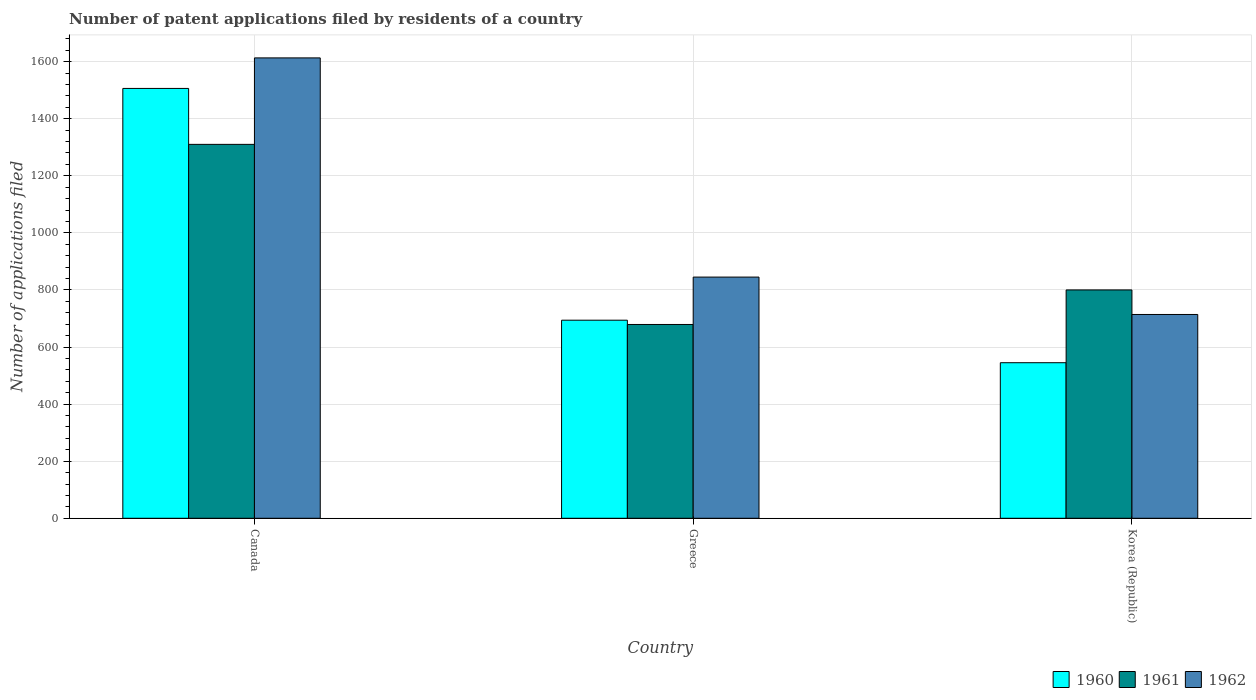How many different coloured bars are there?
Give a very brief answer. 3. What is the label of the 2nd group of bars from the left?
Ensure brevity in your answer.  Greece. In how many cases, is the number of bars for a given country not equal to the number of legend labels?
Make the answer very short. 0. What is the number of applications filed in 1961 in Greece?
Offer a terse response. 679. Across all countries, what is the maximum number of applications filed in 1960?
Give a very brief answer. 1506. Across all countries, what is the minimum number of applications filed in 1961?
Offer a very short reply. 679. In which country was the number of applications filed in 1960 maximum?
Offer a terse response. Canada. What is the total number of applications filed in 1962 in the graph?
Make the answer very short. 3172. What is the difference between the number of applications filed in 1961 in Greece and that in Korea (Republic)?
Make the answer very short. -121. What is the difference between the number of applications filed in 1962 in Canada and the number of applications filed in 1960 in Korea (Republic)?
Your answer should be very brief. 1068. What is the average number of applications filed in 1962 per country?
Your answer should be very brief. 1057.33. What is the difference between the number of applications filed of/in 1961 and number of applications filed of/in 1962 in Greece?
Your answer should be very brief. -166. In how many countries, is the number of applications filed in 1962 greater than 1560?
Offer a very short reply. 1. What is the ratio of the number of applications filed in 1961 in Greece to that in Korea (Republic)?
Offer a very short reply. 0.85. Is the number of applications filed in 1960 in Canada less than that in Korea (Republic)?
Ensure brevity in your answer.  No. Is the difference between the number of applications filed in 1961 in Greece and Korea (Republic) greater than the difference between the number of applications filed in 1962 in Greece and Korea (Republic)?
Provide a succinct answer. No. What is the difference between the highest and the second highest number of applications filed in 1962?
Your answer should be very brief. -131. What is the difference between the highest and the lowest number of applications filed in 1960?
Your answer should be very brief. 961. Is the sum of the number of applications filed in 1962 in Canada and Greece greater than the maximum number of applications filed in 1961 across all countries?
Your answer should be compact. Yes. What does the 2nd bar from the left in Korea (Republic) represents?
Provide a short and direct response. 1961. Is it the case that in every country, the sum of the number of applications filed in 1962 and number of applications filed in 1961 is greater than the number of applications filed in 1960?
Your answer should be very brief. Yes. Are all the bars in the graph horizontal?
Make the answer very short. No. Are the values on the major ticks of Y-axis written in scientific E-notation?
Ensure brevity in your answer.  No. Does the graph contain any zero values?
Your answer should be compact. No. Does the graph contain grids?
Your answer should be very brief. Yes. Where does the legend appear in the graph?
Ensure brevity in your answer.  Bottom right. How many legend labels are there?
Provide a succinct answer. 3. What is the title of the graph?
Ensure brevity in your answer.  Number of patent applications filed by residents of a country. What is the label or title of the X-axis?
Keep it short and to the point. Country. What is the label or title of the Y-axis?
Ensure brevity in your answer.  Number of applications filed. What is the Number of applications filed of 1960 in Canada?
Provide a succinct answer. 1506. What is the Number of applications filed in 1961 in Canada?
Keep it short and to the point. 1310. What is the Number of applications filed of 1962 in Canada?
Offer a very short reply. 1613. What is the Number of applications filed in 1960 in Greece?
Your response must be concise. 694. What is the Number of applications filed of 1961 in Greece?
Your answer should be very brief. 679. What is the Number of applications filed in 1962 in Greece?
Your answer should be very brief. 845. What is the Number of applications filed of 1960 in Korea (Republic)?
Offer a terse response. 545. What is the Number of applications filed in 1961 in Korea (Republic)?
Offer a very short reply. 800. What is the Number of applications filed in 1962 in Korea (Republic)?
Provide a succinct answer. 714. Across all countries, what is the maximum Number of applications filed in 1960?
Your answer should be compact. 1506. Across all countries, what is the maximum Number of applications filed of 1961?
Make the answer very short. 1310. Across all countries, what is the maximum Number of applications filed in 1962?
Keep it short and to the point. 1613. Across all countries, what is the minimum Number of applications filed in 1960?
Your response must be concise. 545. Across all countries, what is the minimum Number of applications filed in 1961?
Offer a terse response. 679. Across all countries, what is the minimum Number of applications filed in 1962?
Make the answer very short. 714. What is the total Number of applications filed in 1960 in the graph?
Your response must be concise. 2745. What is the total Number of applications filed of 1961 in the graph?
Your answer should be very brief. 2789. What is the total Number of applications filed of 1962 in the graph?
Keep it short and to the point. 3172. What is the difference between the Number of applications filed in 1960 in Canada and that in Greece?
Provide a short and direct response. 812. What is the difference between the Number of applications filed in 1961 in Canada and that in Greece?
Ensure brevity in your answer.  631. What is the difference between the Number of applications filed of 1962 in Canada and that in Greece?
Your answer should be compact. 768. What is the difference between the Number of applications filed of 1960 in Canada and that in Korea (Republic)?
Ensure brevity in your answer.  961. What is the difference between the Number of applications filed of 1961 in Canada and that in Korea (Republic)?
Give a very brief answer. 510. What is the difference between the Number of applications filed of 1962 in Canada and that in Korea (Republic)?
Offer a terse response. 899. What is the difference between the Number of applications filed in 1960 in Greece and that in Korea (Republic)?
Your answer should be compact. 149. What is the difference between the Number of applications filed in 1961 in Greece and that in Korea (Republic)?
Provide a succinct answer. -121. What is the difference between the Number of applications filed in 1962 in Greece and that in Korea (Republic)?
Keep it short and to the point. 131. What is the difference between the Number of applications filed in 1960 in Canada and the Number of applications filed in 1961 in Greece?
Make the answer very short. 827. What is the difference between the Number of applications filed in 1960 in Canada and the Number of applications filed in 1962 in Greece?
Ensure brevity in your answer.  661. What is the difference between the Number of applications filed in 1961 in Canada and the Number of applications filed in 1962 in Greece?
Ensure brevity in your answer.  465. What is the difference between the Number of applications filed in 1960 in Canada and the Number of applications filed in 1961 in Korea (Republic)?
Keep it short and to the point. 706. What is the difference between the Number of applications filed of 1960 in Canada and the Number of applications filed of 1962 in Korea (Republic)?
Provide a short and direct response. 792. What is the difference between the Number of applications filed in 1961 in Canada and the Number of applications filed in 1962 in Korea (Republic)?
Ensure brevity in your answer.  596. What is the difference between the Number of applications filed of 1960 in Greece and the Number of applications filed of 1961 in Korea (Republic)?
Provide a succinct answer. -106. What is the difference between the Number of applications filed in 1960 in Greece and the Number of applications filed in 1962 in Korea (Republic)?
Keep it short and to the point. -20. What is the difference between the Number of applications filed in 1961 in Greece and the Number of applications filed in 1962 in Korea (Republic)?
Your answer should be very brief. -35. What is the average Number of applications filed in 1960 per country?
Give a very brief answer. 915. What is the average Number of applications filed of 1961 per country?
Keep it short and to the point. 929.67. What is the average Number of applications filed of 1962 per country?
Your answer should be very brief. 1057.33. What is the difference between the Number of applications filed in 1960 and Number of applications filed in 1961 in Canada?
Your response must be concise. 196. What is the difference between the Number of applications filed in 1960 and Number of applications filed in 1962 in Canada?
Offer a very short reply. -107. What is the difference between the Number of applications filed in 1961 and Number of applications filed in 1962 in Canada?
Your response must be concise. -303. What is the difference between the Number of applications filed in 1960 and Number of applications filed in 1962 in Greece?
Your answer should be very brief. -151. What is the difference between the Number of applications filed of 1961 and Number of applications filed of 1962 in Greece?
Provide a succinct answer. -166. What is the difference between the Number of applications filed in 1960 and Number of applications filed in 1961 in Korea (Republic)?
Ensure brevity in your answer.  -255. What is the difference between the Number of applications filed in 1960 and Number of applications filed in 1962 in Korea (Republic)?
Make the answer very short. -169. What is the ratio of the Number of applications filed of 1960 in Canada to that in Greece?
Provide a succinct answer. 2.17. What is the ratio of the Number of applications filed of 1961 in Canada to that in Greece?
Your answer should be very brief. 1.93. What is the ratio of the Number of applications filed of 1962 in Canada to that in Greece?
Offer a very short reply. 1.91. What is the ratio of the Number of applications filed of 1960 in Canada to that in Korea (Republic)?
Keep it short and to the point. 2.76. What is the ratio of the Number of applications filed of 1961 in Canada to that in Korea (Republic)?
Offer a terse response. 1.64. What is the ratio of the Number of applications filed in 1962 in Canada to that in Korea (Republic)?
Give a very brief answer. 2.26. What is the ratio of the Number of applications filed in 1960 in Greece to that in Korea (Republic)?
Keep it short and to the point. 1.27. What is the ratio of the Number of applications filed in 1961 in Greece to that in Korea (Republic)?
Offer a terse response. 0.85. What is the ratio of the Number of applications filed in 1962 in Greece to that in Korea (Republic)?
Ensure brevity in your answer.  1.18. What is the difference between the highest and the second highest Number of applications filed in 1960?
Your answer should be compact. 812. What is the difference between the highest and the second highest Number of applications filed of 1961?
Give a very brief answer. 510. What is the difference between the highest and the second highest Number of applications filed of 1962?
Provide a succinct answer. 768. What is the difference between the highest and the lowest Number of applications filed in 1960?
Keep it short and to the point. 961. What is the difference between the highest and the lowest Number of applications filed in 1961?
Your answer should be very brief. 631. What is the difference between the highest and the lowest Number of applications filed of 1962?
Give a very brief answer. 899. 